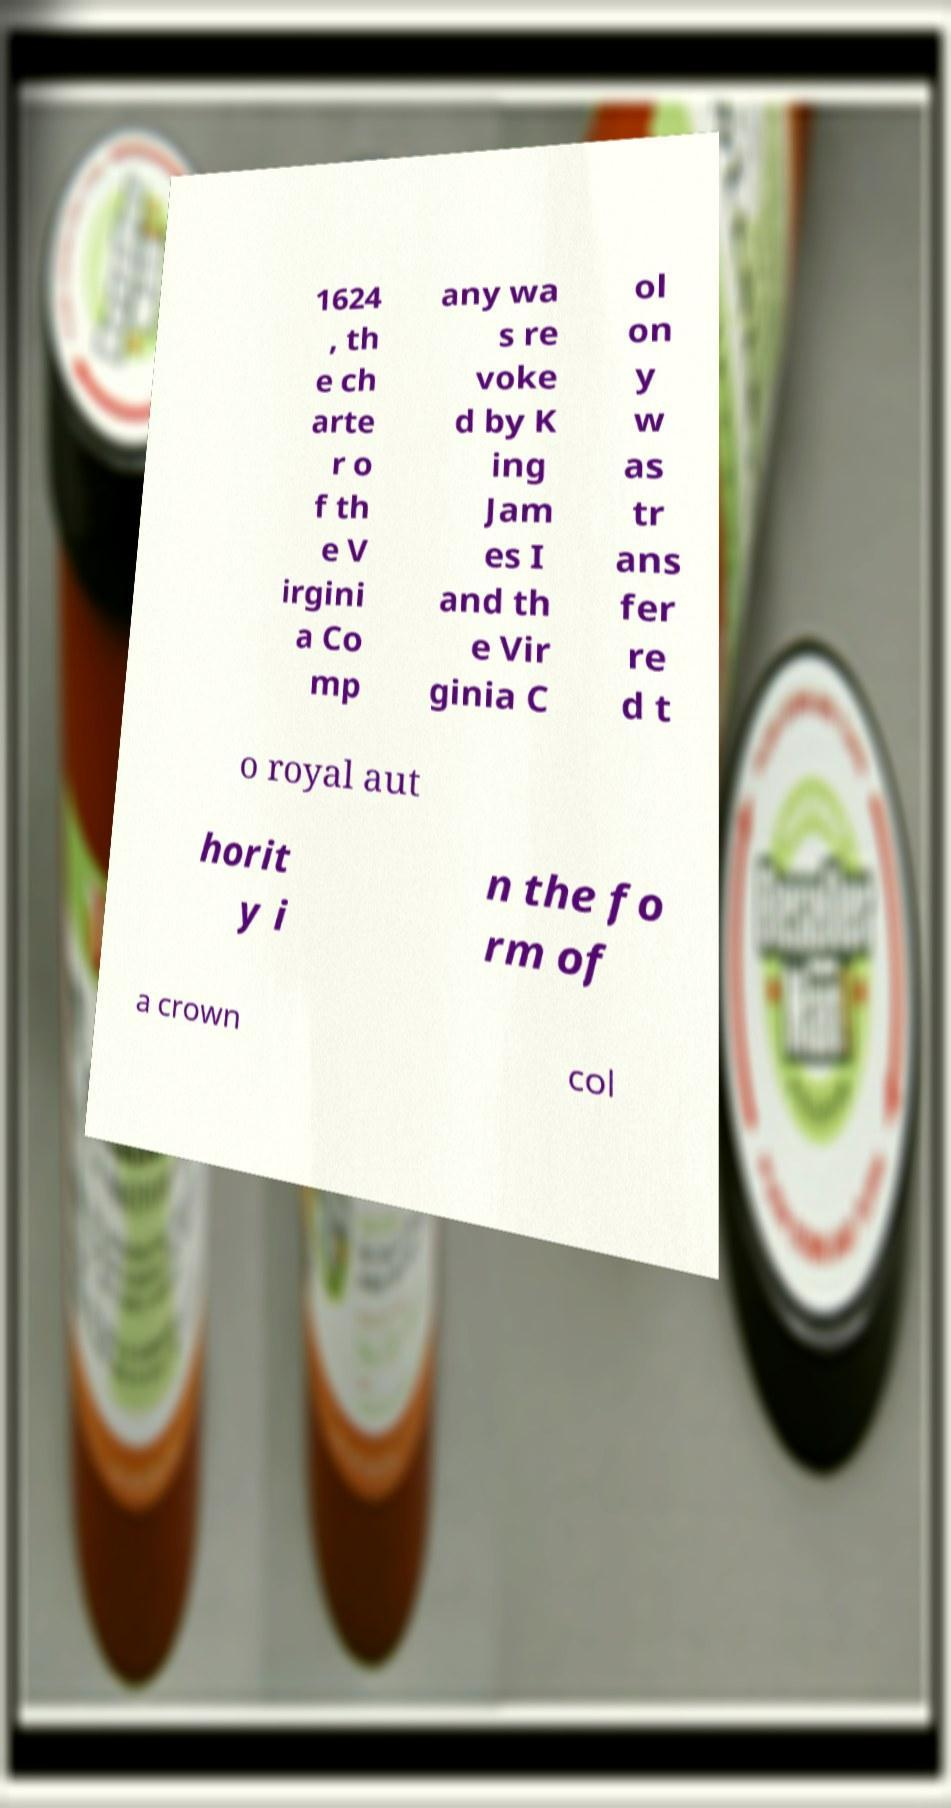Please read and relay the text visible in this image. What does it say? 1624 , th e ch arte r o f th e V irgini a Co mp any wa s re voke d by K ing Jam es I and th e Vir ginia C ol on y w as tr ans fer re d t o royal aut horit y i n the fo rm of a crown col 